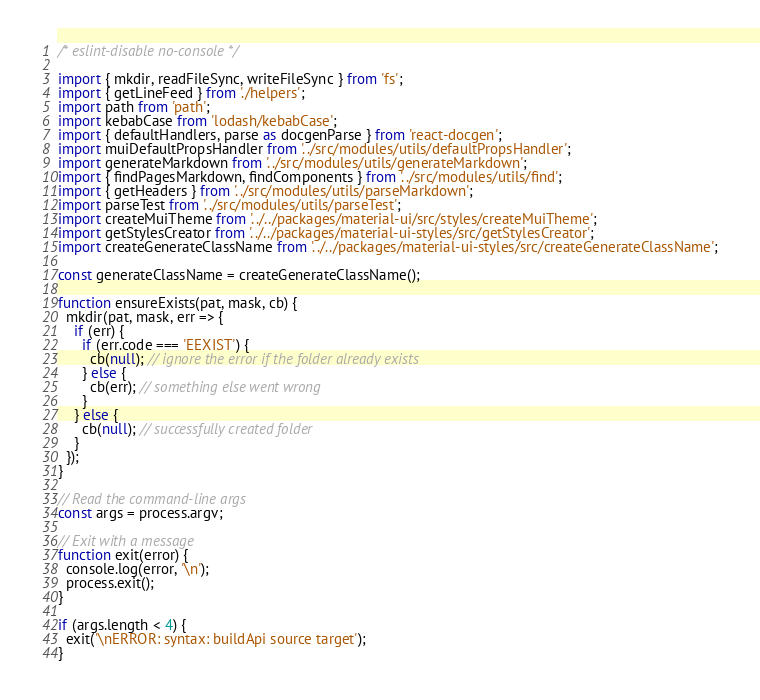Convert code to text. <code><loc_0><loc_0><loc_500><loc_500><_JavaScript_>/* eslint-disable no-console */

import { mkdir, readFileSync, writeFileSync } from 'fs';
import { getLineFeed } from './helpers';
import path from 'path';
import kebabCase from 'lodash/kebabCase';
import { defaultHandlers, parse as docgenParse } from 'react-docgen';
import muiDefaultPropsHandler from '../src/modules/utils/defaultPropsHandler';
import generateMarkdown from '../src/modules/utils/generateMarkdown';
import { findPagesMarkdown, findComponents } from '../src/modules/utils/find';
import { getHeaders } from '../src/modules/utils/parseMarkdown';
import parseTest from '../src/modules/utils/parseTest';
import createMuiTheme from '../../packages/material-ui/src/styles/createMuiTheme';
import getStylesCreator from '../../packages/material-ui-styles/src/getStylesCreator';
import createGenerateClassName from '../../packages/material-ui-styles/src/createGenerateClassName';

const generateClassName = createGenerateClassName();

function ensureExists(pat, mask, cb) {
  mkdir(pat, mask, err => {
    if (err) {
      if (err.code === 'EEXIST') {
        cb(null); // ignore the error if the folder already exists
      } else {
        cb(err); // something else went wrong
      }
    } else {
      cb(null); // successfully created folder
    }
  });
}

// Read the command-line args
const args = process.argv;

// Exit with a message
function exit(error) {
  console.log(error, '\n');
  process.exit();
}

if (args.length < 4) {
  exit('\nERROR: syntax: buildApi source target');
}
</code> 